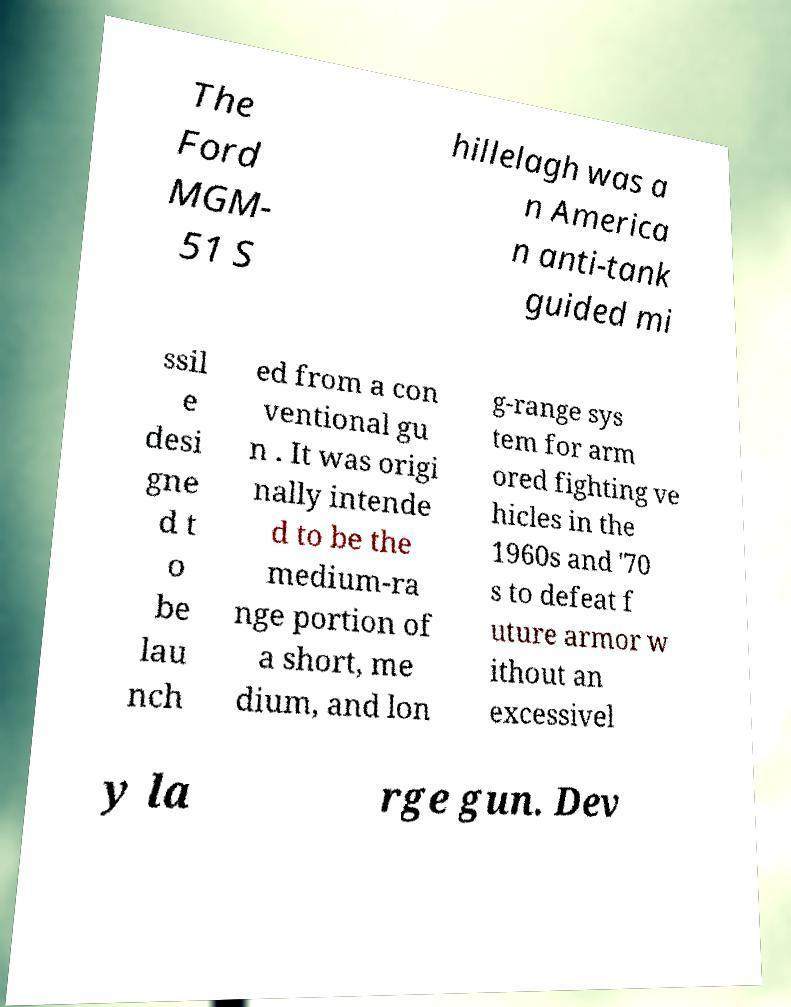I need the written content from this picture converted into text. Can you do that? The Ford MGM- 51 S hillelagh was a n America n anti-tank guided mi ssil e desi gne d t o be lau nch ed from a con ventional gu n . It was origi nally intende d to be the medium-ra nge portion of a short, me dium, and lon g-range sys tem for arm ored fighting ve hicles in the 1960s and '70 s to defeat f uture armor w ithout an excessivel y la rge gun. Dev 